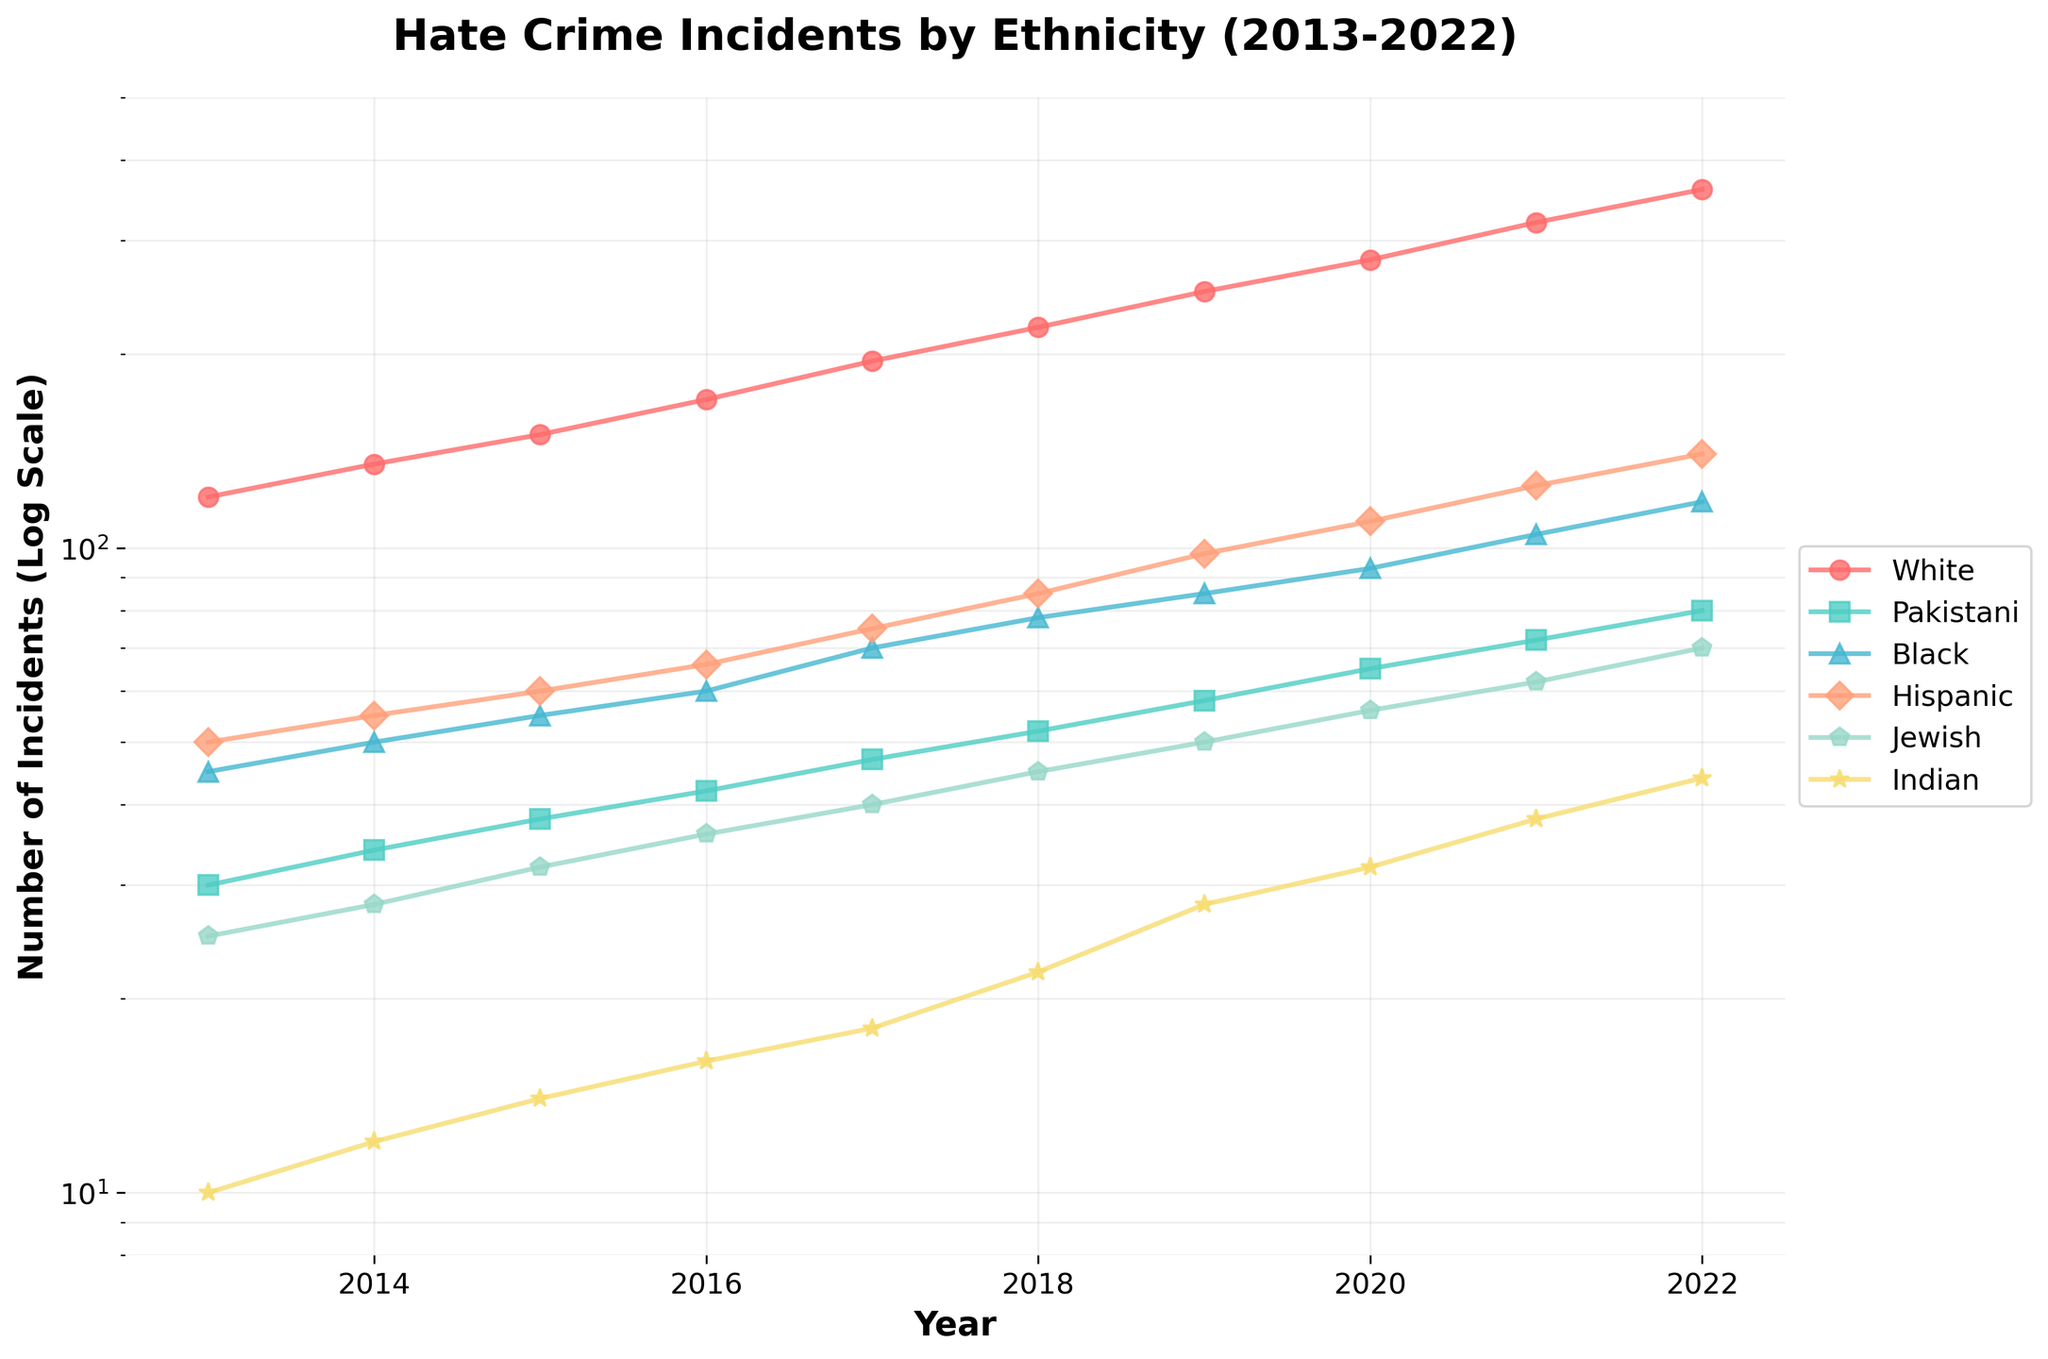what is the title of the plot? You can see the title at the top of the plot. It reads "Hate Crime Incidents by Ethnicity (2013-2022)".
Answer: Hate Crime Incidents by Ethnicity (2013-2022) Which ethnicity saw the highest number of hate crime incidents in 2022? By examining the final data points for each line in the plot for the year 2022, the line representing White ethnicity has the highest value.
Answer: White How many ethnicities are represented in the plot? The legend at the side of the plot lists each ethnicity's name. There are six ethnicities in total: White, Pakistani, Black, Hispanic, Jewish, and Indian.
Answer: 6 What was the number of hate crime incidents for Hispanic ethnicity in 2018? Locate the year 2018 on the X-axis and follow it up to the line representing Hispanic ethnicity, marked with a circle. The data point corresponds to 85 incidents.
Answer: 85 How did the number of incidents for the Black ethnicity change from 2017 to 2018? Identify the data points for Black ethnicity in both years 2017 and 2018. In 2017, the number is 70, and in 2018, it is 78. The difference is 78 - 70 = 8.
Answer: Increased by 8 Which two ethnicities had the closest number of incidents in 2020? Look at the data points for 2020. Both Hispanic and White ethnicities have data points close to each other, 110 and 280, respectively. Compare the rest to find Jewish and Indian are also close but are not the nearest.
Answer: Hispanic and Jewish What has been the general trend in hate crime incidents against the Jewish ethnicity over the decade? Observe the overall pattern of the line representing Jewish ethnicity, which shows a consistent increase from 2013 to 2022.
Answer: Increasing trend In which year did the incidents of hate crimes against Pakistani ethnicity surpass 50 for the first time? Follow the Pakistani line and find the first year in which it crosses the 50 mark. The data point corresponding to 2018 surpasses with 52 incidents.
Answer: 2018 Among the ethnicities, whose hate crimes increased the least from 2013 to 2022? Calculate the difference for each ethnicity between 2013 and 2022, then compare the differences. Indian increased from 10 to 44, the smallest increment of 34.
Answer: Indian What shape of markers represents the data points for Black ethnicity? By examining how data points are marked, you will notice that Black ethnicity is represented by triangular (^) markers.
Answer: Triangle 